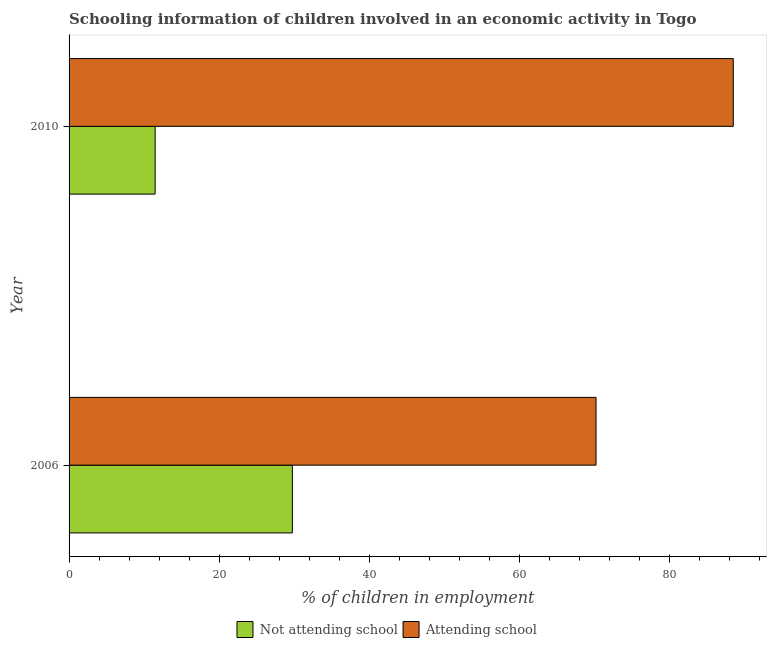How many different coloured bars are there?
Keep it short and to the point. 2. How many groups of bars are there?
Make the answer very short. 2. What is the label of the 2nd group of bars from the top?
Make the answer very short. 2006. In how many cases, is the number of bars for a given year not equal to the number of legend labels?
Provide a succinct answer. 0. What is the percentage of employed children who are attending school in 2006?
Give a very brief answer. 70.24. Across all years, what is the maximum percentage of employed children who are not attending school?
Offer a terse response. 29.76. Across all years, what is the minimum percentage of employed children who are not attending school?
Your answer should be compact. 11.47. What is the total percentage of employed children who are not attending school in the graph?
Give a very brief answer. 41.23. What is the difference between the percentage of employed children who are not attending school in 2006 and that in 2010?
Give a very brief answer. 18.29. What is the difference between the percentage of employed children who are attending school in 2010 and the percentage of employed children who are not attending school in 2006?
Provide a succinct answer. 58.77. What is the average percentage of employed children who are attending school per year?
Ensure brevity in your answer.  79.38. In the year 2006, what is the difference between the percentage of employed children who are not attending school and percentage of employed children who are attending school?
Provide a short and direct response. -40.47. In how many years, is the percentage of employed children who are attending school greater than 72 %?
Provide a succinct answer. 1. What is the ratio of the percentage of employed children who are attending school in 2006 to that in 2010?
Offer a terse response. 0.79. In how many years, is the percentage of employed children who are not attending school greater than the average percentage of employed children who are not attending school taken over all years?
Offer a very short reply. 1. What does the 1st bar from the top in 2006 represents?
Give a very brief answer. Attending school. What does the 1st bar from the bottom in 2010 represents?
Keep it short and to the point. Not attending school. How many bars are there?
Your answer should be compact. 4. Are all the bars in the graph horizontal?
Make the answer very short. Yes. Does the graph contain any zero values?
Your response must be concise. No. Where does the legend appear in the graph?
Make the answer very short. Bottom center. How many legend labels are there?
Keep it short and to the point. 2. What is the title of the graph?
Your response must be concise. Schooling information of children involved in an economic activity in Togo. What is the label or title of the X-axis?
Your answer should be very brief. % of children in employment. What is the label or title of the Y-axis?
Offer a terse response. Year. What is the % of children in employment in Not attending school in 2006?
Your response must be concise. 29.76. What is the % of children in employment in Attending school in 2006?
Offer a terse response. 70.24. What is the % of children in employment in Not attending school in 2010?
Offer a terse response. 11.47. What is the % of children in employment in Attending school in 2010?
Keep it short and to the point. 88.53. Across all years, what is the maximum % of children in employment of Not attending school?
Offer a terse response. 29.76. Across all years, what is the maximum % of children in employment of Attending school?
Your answer should be compact. 88.53. Across all years, what is the minimum % of children in employment in Not attending school?
Offer a very short reply. 11.47. Across all years, what is the minimum % of children in employment in Attending school?
Your answer should be compact. 70.24. What is the total % of children in employment in Not attending school in the graph?
Offer a very short reply. 41.23. What is the total % of children in employment of Attending school in the graph?
Your answer should be very brief. 158.77. What is the difference between the % of children in employment in Not attending school in 2006 and that in 2010?
Provide a succinct answer. 18.29. What is the difference between the % of children in employment in Attending school in 2006 and that in 2010?
Offer a very short reply. -18.29. What is the difference between the % of children in employment in Not attending school in 2006 and the % of children in employment in Attending school in 2010?
Give a very brief answer. -58.77. What is the average % of children in employment in Not attending school per year?
Offer a terse response. 20.62. What is the average % of children in employment in Attending school per year?
Provide a short and direct response. 79.38. In the year 2006, what is the difference between the % of children in employment in Not attending school and % of children in employment in Attending school?
Give a very brief answer. -40.47. In the year 2010, what is the difference between the % of children in employment in Not attending school and % of children in employment in Attending school?
Your answer should be compact. -77.06. What is the ratio of the % of children in employment of Not attending school in 2006 to that in 2010?
Provide a succinct answer. 2.59. What is the ratio of the % of children in employment in Attending school in 2006 to that in 2010?
Ensure brevity in your answer.  0.79. What is the difference between the highest and the second highest % of children in employment of Not attending school?
Make the answer very short. 18.29. What is the difference between the highest and the second highest % of children in employment in Attending school?
Offer a very short reply. 18.29. What is the difference between the highest and the lowest % of children in employment of Not attending school?
Ensure brevity in your answer.  18.29. What is the difference between the highest and the lowest % of children in employment of Attending school?
Your answer should be compact. 18.29. 